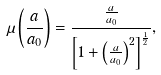Convert formula to latex. <formula><loc_0><loc_0><loc_500><loc_500>\mu \left ( \frac { a } { a _ { 0 } } \right ) = \frac { \frac { a } { a _ { 0 } } } { \left [ 1 + \left ( \frac { a } { a _ { 0 } } \right ) ^ { 2 } \right ] ^ { \frac { 1 } { 2 } } } ,</formula> 